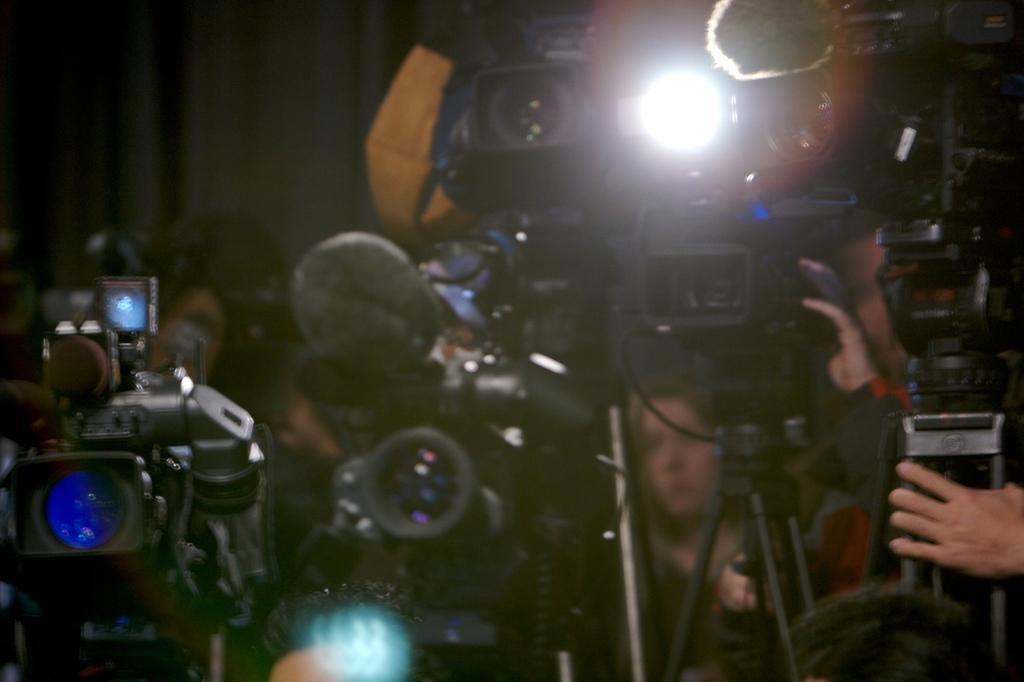Describe this image in one or two sentences. In the picture I can see few cameras placed on the stand and there are few persons behind it. 